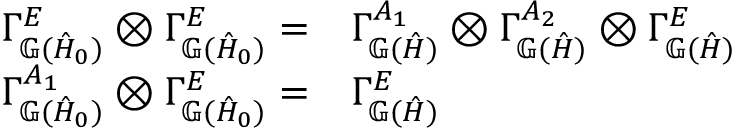<formula> <loc_0><loc_0><loc_500><loc_500>\begin{array} { r } { \begin{array} { r l } { \Gamma _ { \mathbb { G } ( \hat { H } _ { 0 } ) } ^ { E } \otimes \Gamma _ { \mathbb { G } ( \hat { H } _ { 0 } ) } ^ { E } = } & { \Gamma _ { \mathbb { G } ( \hat { H } ) } ^ { A _ { 1 } } \otimes \Gamma _ { \mathbb { G } ( \hat { H } ) } ^ { A _ { 2 } } \otimes \Gamma _ { \mathbb { G } ( \hat { H } ) } ^ { E } } \\ { \Gamma _ { \mathbb { G } ( \hat { H } _ { 0 } ) } ^ { A _ { 1 } } \otimes \Gamma _ { \mathbb { G } ( \hat { H } _ { 0 } ) } ^ { E } = } & { \Gamma _ { \mathbb { G } ( \hat { H } ) } ^ { E } } \end{array} } \end{array}</formula> 